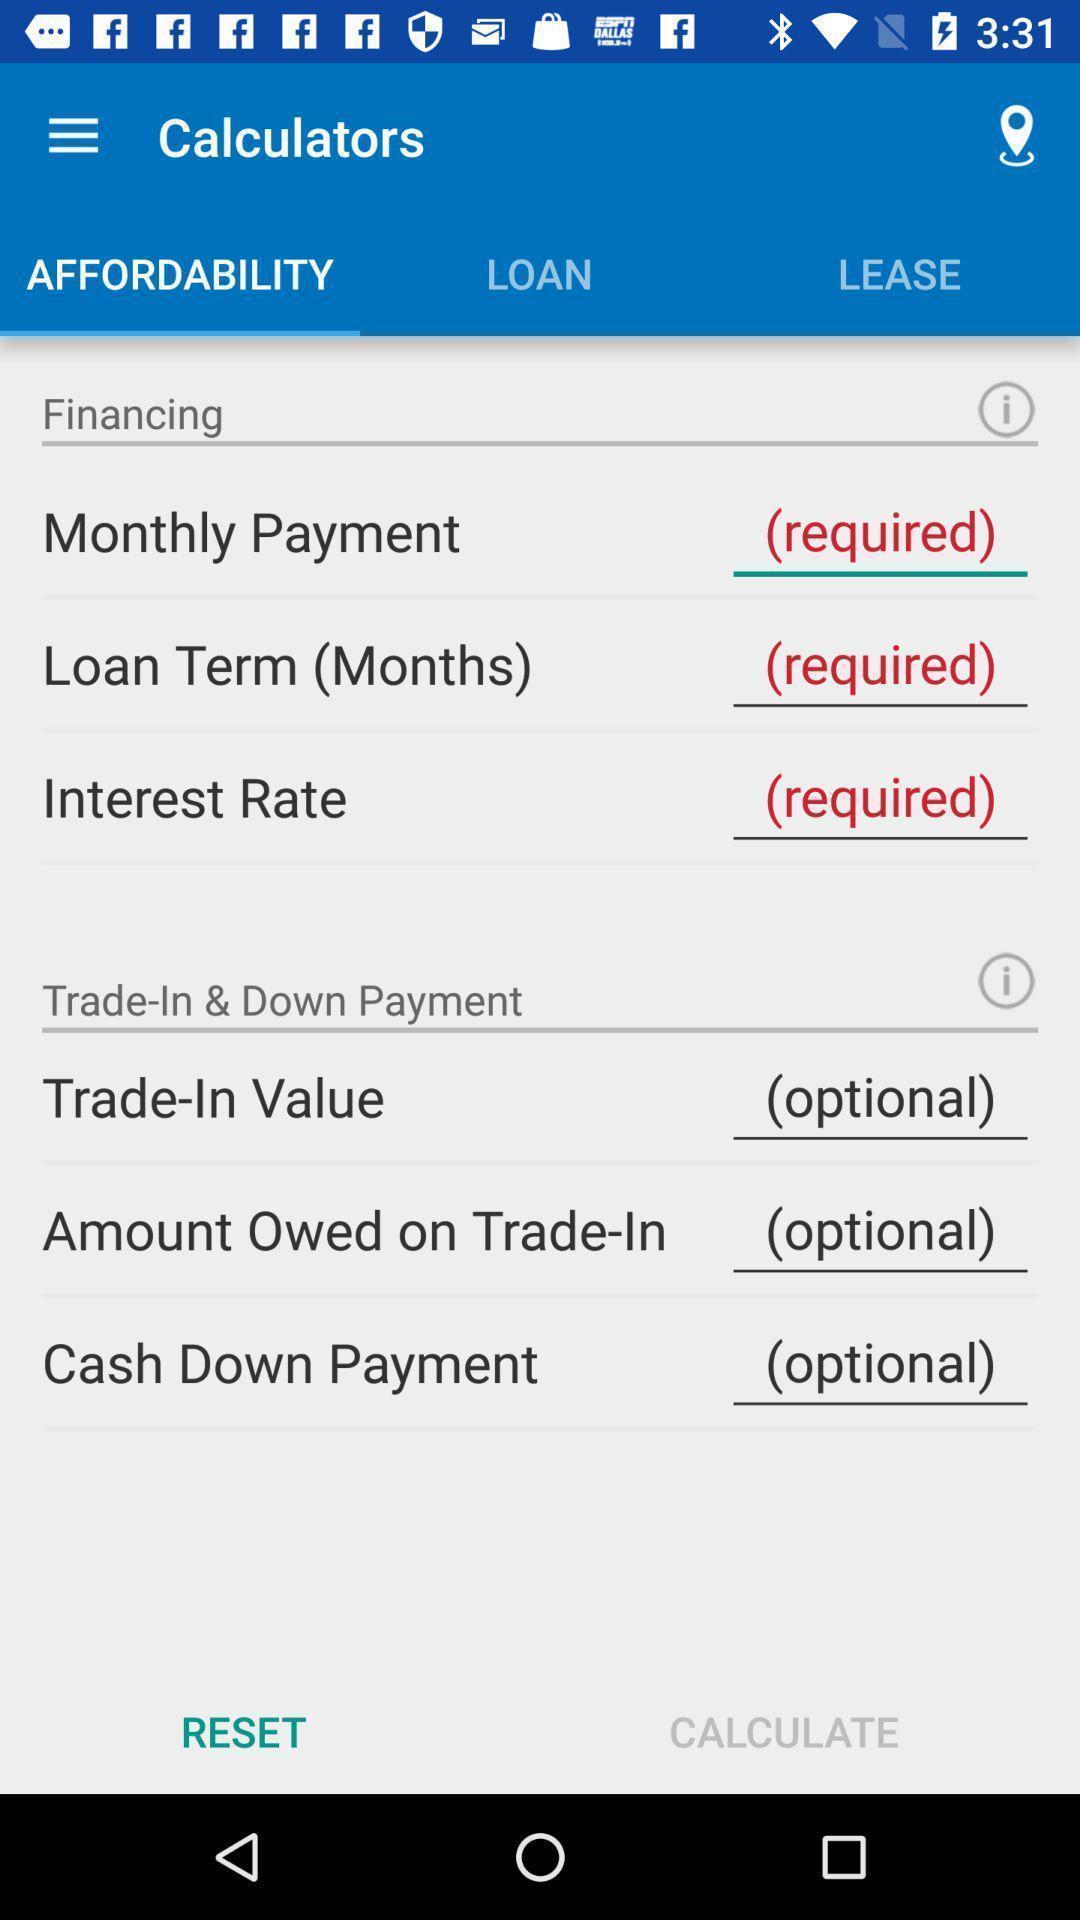Summarize the main components in this picture. Page showing financing calculators. 